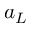<formula> <loc_0><loc_0><loc_500><loc_500>a _ { L }</formula> 